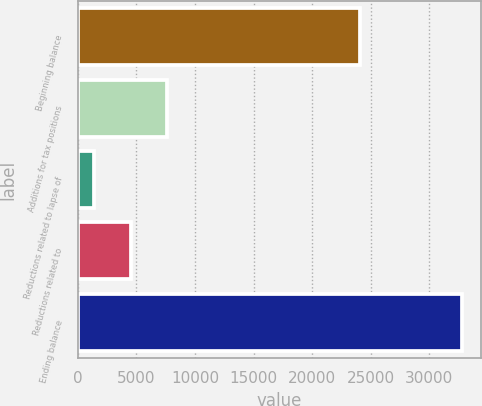Convert chart. <chart><loc_0><loc_0><loc_500><loc_500><bar_chart><fcel>Beginning balance<fcel>Additions for tax positions<fcel>Reductions related to lapse of<fcel>Reductions related to<fcel>Ending balance<nl><fcel>24066<fcel>7659.2<fcel>1380<fcel>4519.6<fcel>32776<nl></chart> 